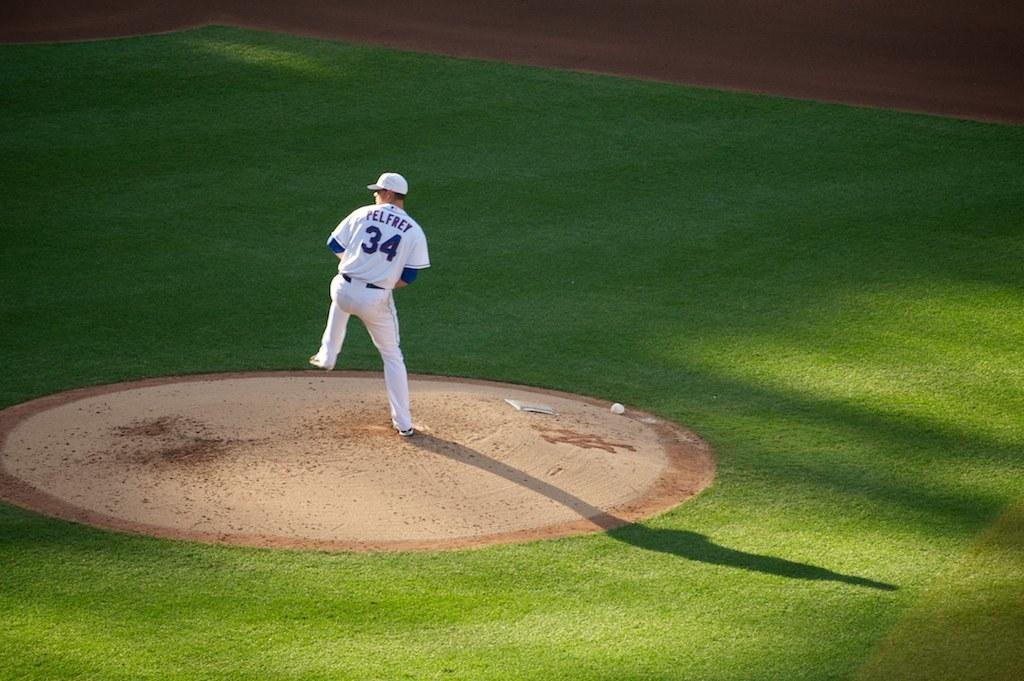What is the players last name?
Offer a very short reply. Pelfrey. 